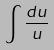<formula> <loc_0><loc_0><loc_500><loc_500>\int \frac { d u } { u }</formula> 